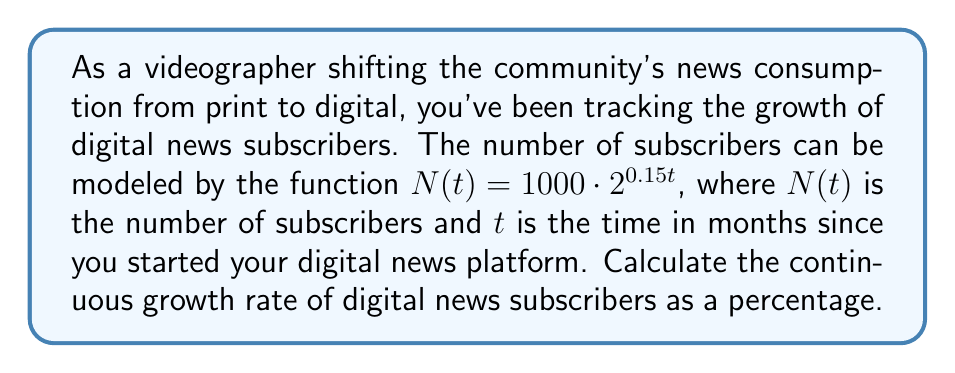What is the answer to this math problem? To solve this problem, we need to understand that the continuous growth rate is represented by the coefficient of $t$ in the exponent when the function is written in the form $N(t) = N_0 \cdot e^{rt}$, where $r$ is the continuous growth rate.

Given function: $N(t) = 1000 \cdot 2^{0.15t}$

Step 1: Rewrite the function using the property of exponents: $a^b = e^{b \ln(a)}$
$$N(t) = 1000 \cdot (e^{\ln(2)})^{0.15t}$$

Step 2: Simplify using the power rule of exponents: $(a^b)^c = a^{bc}$
$$N(t) = 1000 \cdot e^{0.15t \ln(2)}$$

Step 3: The continuous growth rate $r$ is the coefficient of $t$ in the exponent
$$r = 0.15 \ln(2)$$

Step 4: Calculate the value of $r$
$$r = 0.15 \cdot \ln(2) \approx 0.15 \cdot 0.6931 \approx 0.10397$$

Step 5: Convert to a percentage by multiplying by 100
$$\text{Growth rate} = 0.10397 \cdot 100\% \approx 10.40\%$$
Answer: The continuous growth rate of digital news subscribers is approximately 10.40%. 